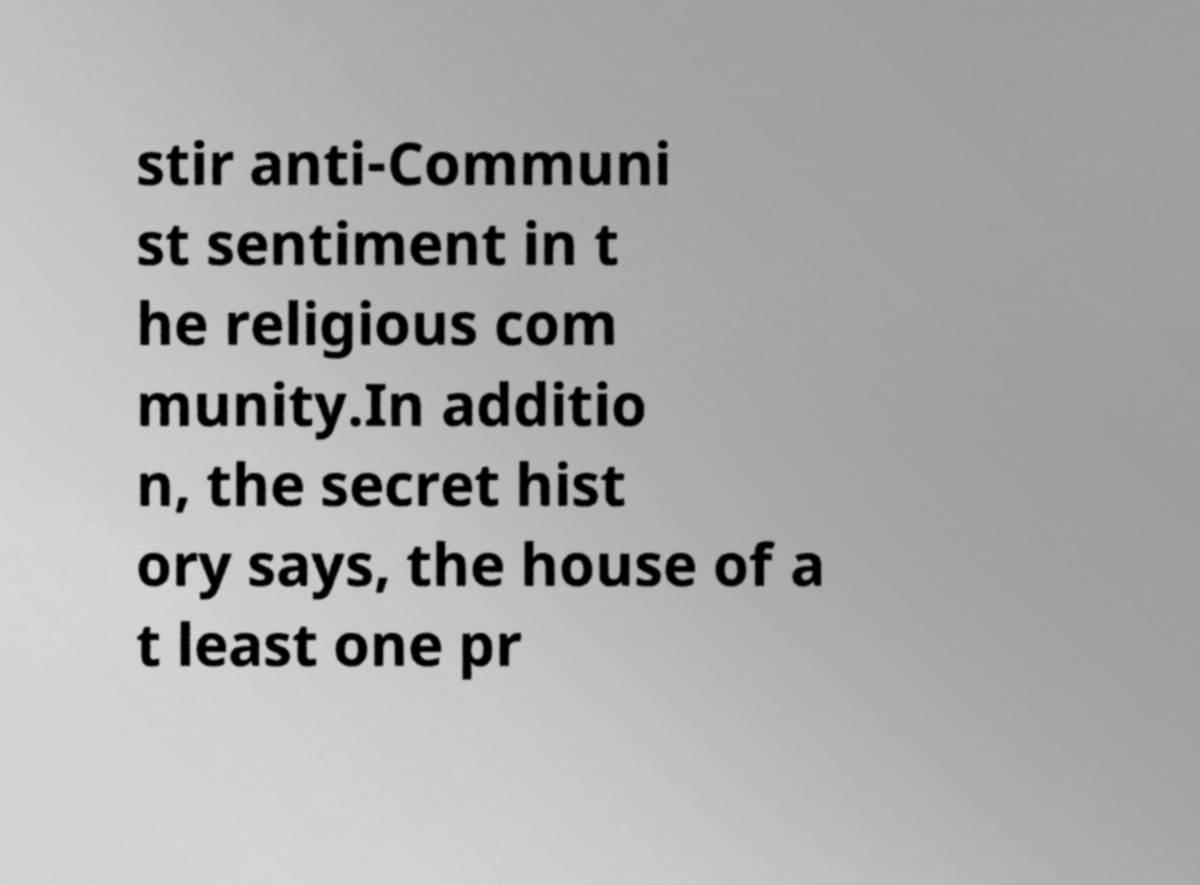Could you extract and type out the text from this image? stir anti-Communi st sentiment in t he religious com munity.In additio n, the secret hist ory says, the house of a t least one pr 